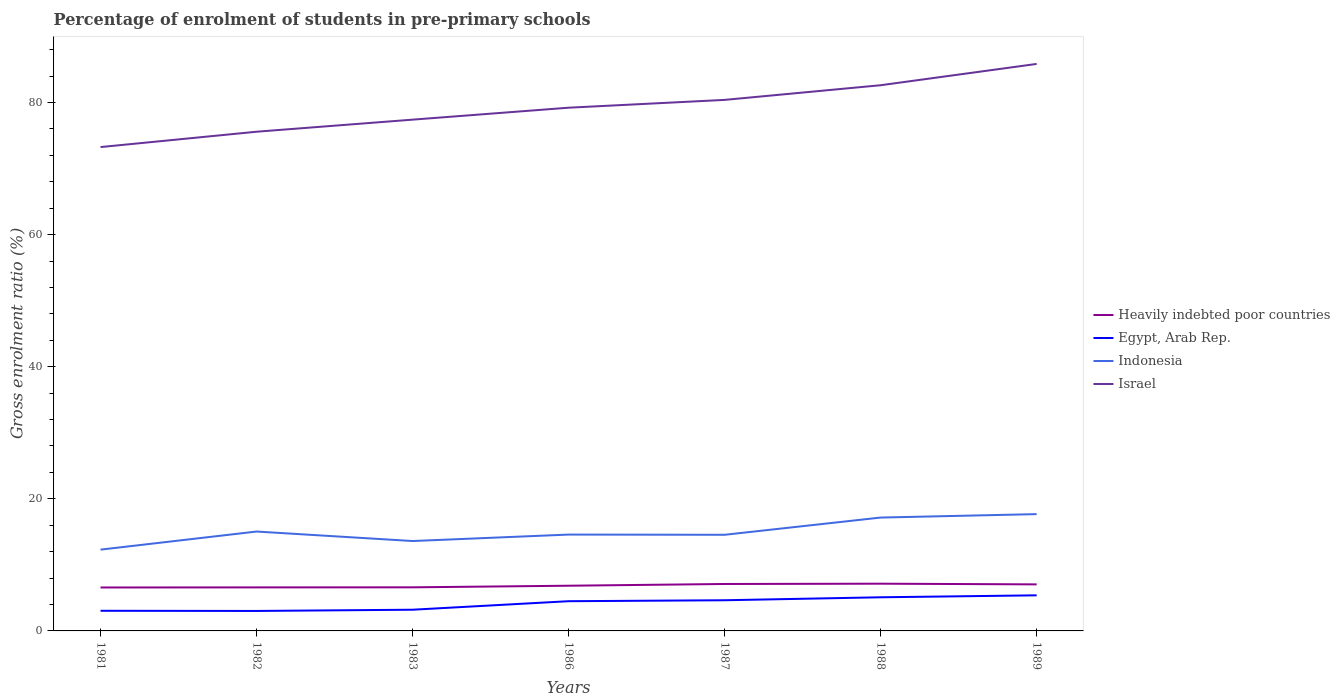How many different coloured lines are there?
Ensure brevity in your answer.  4. Does the line corresponding to Israel intersect with the line corresponding to Egypt, Arab Rep.?
Your answer should be compact. No. Is the number of lines equal to the number of legend labels?
Make the answer very short. Yes. Across all years, what is the maximum percentage of students enrolled in pre-primary schools in Indonesia?
Your answer should be compact. 12.31. What is the total percentage of students enrolled in pre-primary schools in Heavily indebted poor countries in the graph?
Give a very brief answer. -0.27. What is the difference between the highest and the second highest percentage of students enrolled in pre-primary schools in Indonesia?
Make the answer very short. 5.38. How many lines are there?
Your response must be concise. 4. How many years are there in the graph?
Make the answer very short. 7. Does the graph contain any zero values?
Your response must be concise. No. What is the title of the graph?
Provide a short and direct response. Percentage of enrolment of students in pre-primary schools. What is the label or title of the Y-axis?
Make the answer very short. Gross enrolment ratio (%). What is the Gross enrolment ratio (%) of Heavily indebted poor countries in 1981?
Your response must be concise. 6.58. What is the Gross enrolment ratio (%) in Egypt, Arab Rep. in 1981?
Your answer should be very brief. 3.05. What is the Gross enrolment ratio (%) in Indonesia in 1981?
Your answer should be very brief. 12.31. What is the Gross enrolment ratio (%) of Israel in 1981?
Keep it short and to the point. 73.25. What is the Gross enrolment ratio (%) in Heavily indebted poor countries in 1982?
Provide a succinct answer. 6.59. What is the Gross enrolment ratio (%) of Egypt, Arab Rep. in 1982?
Ensure brevity in your answer.  3.02. What is the Gross enrolment ratio (%) of Indonesia in 1982?
Your response must be concise. 15.04. What is the Gross enrolment ratio (%) in Israel in 1982?
Give a very brief answer. 75.57. What is the Gross enrolment ratio (%) in Heavily indebted poor countries in 1983?
Your answer should be very brief. 6.6. What is the Gross enrolment ratio (%) in Egypt, Arab Rep. in 1983?
Make the answer very short. 3.21. What is the Gross enrolment ratio (%) of Indonesia in 1983?
Offer a terse response. 13.61. What is the Gross enrolment ratio (%) of Israel in 1983?
Your answer should be very brief. 77.4. What is the Gross enrolment ratio (%) in Heavily indebted poor countries in 1986?
Provide a succinct answer. 6.84. What is the Gross enrolment ratio (%) in Egypt, Arab Rep. in 1986?
Your answer should be compact. 4.5. What is the Gross enrolment ratio (%) in Indonesia in 1986?
Offer a terse response. 14.59. What is the Gross enrolment ratio (%) in Israel in 1986?
Provide a succinct answer. 79.21. What is the Gross enrolment ratio (%) of Heavily indebted poor countries in 1987?
Provide a succinct answer. 7.11. What is the Gross enrolment ratio (%) in Egypt, Arab Rep. in 1987?
Your answer should be compact. 4.64. What is the Gross enrolment ratio (%) of Indonesia in 1987?
Offer a very short reply. 14.55. What is the Gross enrolment ratio (%) of Israel in 1987?
Your answer should be compact. 80.39. What is the Gross enrolment ratio (%) of Heavily indebted poor countries in 1988?
Your response must be concise. 7.15. What is the Gross enrolment ratio (%) of Egypt, Arab Rep. in 1988?
Your answer should be very brief. 5.09. What is the Gross enrolment ratio (%) in Indonesia in 1988?
Offer a very short reply. 17.16. What is the Gross enrolment ratio (%) in Israel in 1988?
Your answer should be very brief. 82.61. What is the Gross enrolment ratio (%) in Heavily indebted poor countries in 1989?
Your answer should be very brief. 7.05. What is the Gross enrolment ratio (%) of Egypt, Arab Rep. in 1989?
Your answer should be compact. 5.39. What is the Gross enrolment ratio (%) of Indonesia in 1989?
Ensure brevity in your answer.  17.68. What is the Gross enrolment ratio (%) in Israel in 1989?
Offer a very short reply. 85.83. Across all years, what is the maximum Gross enrolment ratio (%) of Heavily indebted poor countries?
Your answer should be compact. 7.15. Across all years, what is the maximum Gross enrolment ratio (%) in Egypt, Arab Rep.?
Make the answer very short. 5.39. Across all years, what is the maximum Gross enrolment ratio (%) of Indonesia?
Make the answer very short. 17.68. Across all years, what is the maximum Gross enrolment ratio (%) of Israel?
Make the answer very short. 85.83. Across all years, what is the minimum Gross enrolment ratio (%) in Heavily indebted poor countries?
Your answer should be very brief. 6.58. Across all years, what is the minimum Gross enrolment ratio (%) of Egypt, Arab Rep.?
Offer a very short reply. 3.02. Across all years, what is the minimum Gross enrolment ratio (%) in Indonesia?
Ensure brevity in your answer.  12.31. Across all years, what is the minimum Gross enrolment ratio (%) of Israel?
Give a very brief answer. 73.25. What is the total Gross enrolment ratio (%) in Heavily indebted poor countries in the graph?
Offer a terse response. 47.91. What is the total Gross enrolment ratio (%) in Egypt, Arab Rep. in the graph?
Make the answer very short. 28.91. What is the total Gross enrolment ratio (%) in Indonesia in the graph?
Offer a very short reply. 104.94. What is the total Gross enrolment ratio (%) of Israel in the graph?
Your response must be concise. 554.26. What is the difference between the Gross enrolment ratio (%) of Heavily indebted poor countries in 1981 and that in 1982?
Make the answer very short. -0.01. What is the difference between the Gross enrolment ratio (%) in Egypt, Arab Rep. in 1981 and that in 1982?
Ensure brevity in your answer.  0.03. What is the difference between the Gross enrolment ratio (%) in Indonesia in 1981 and that in 1982?
Offer a terse response. -2.74. What is the difference between the Gross enrolment ratio (%) of Israel in 1981 and that in 1982?
Offer a terse response. -2.32. What is the difference between the Gross enrolment ratio (%) of Heavily indebted poor countries in 1981 and that in 1983?
Ensure brevity in your answer.  -0.02. What is the difference between the Gross enrolment ratio (%) of Egypt, Arab Rep. in 1981 and that in 1983?
Provide a short and direct response. -0.16. What is the difference between the Gross enrolment ratio (%) in Indonesia in 1981 and that in 1983?
Provide a succinct answer. -1.3. What is the difference between the Gross enrolment ratio (%) of Israel in 1981 and that in 1983?
Ensure brevity in your answer.  -4.15. What is the difference between the Gross enrolment ratio (%) in Heavily indebted poor countries in 1981 and that in 1986?
Your answer should be very brief. -0.27. What is the difference between the Gross enrolment ratio (%) of Egypt, Arab Rep. in 1981 and that in 1986?
Your response must be concise. -1.45. What is the difference between the Gross enrolment ratio (%) of Indonesia in 1981 and that in 1986?
Keep it short and to the point. -2.28. What is the difference between the Gross enrolment ratio (%) of Israel in 1981 and that in 1986?
Your answer should be compact. -5.96. What is the difference between the Gross enrolment ratio (%) in Heavily indebted poor countries in 1981 and that in 1987?
Your response must be concise. -0.53. What is the difference between the Gross enrolment ratio (%) in Egypt, Arab Rep. in 1981 and that in 1987?
Make the answer very short. -1.59. What is the difference between the Gross enrolment ratio (%) of Indonesia in 1981 and that in 1987?
Offer a terse response. -2.25. What is the difference between the Gross enrolment ratio (%) of Israel in 1981 and that in 1987?
Your answer should be very brief. -7.14. What is the difference between the Gross enrolment ratio (%) of Heavily indebted poor countries in 1981 and that in 1988?
Keep it short and to the point. -0.57. What is the difference between the Gross enrolment ratio (%) in Egypt, Arab Rep. in 1981 and that in 1988?
Your answer should be very brief. -2.04. What is the difference between the Gross enrolment ratio (%) in Indonesia in 1981 and that in 1988?
Offer a terse response. -4.86. What is the difference between the Gross enrolment ratio (%) of Israel in 1981 and that in 1988?
Make the answer very short. -9.36. What is the difference between the Gross enrolment ratio (%) in Heavily indebted poor countries in 1981 and that in 1989?
Offer a very short reply. -0.47. What is the difference between the Gross enrolment ratio (%) of Egypt, Arab Rep. in 1981 and that in 1989?
Make the answer very short. -2.34. What is the difference between the Gross enrolment ratio (%) of Indonesia in 1981 and that in 1989?
Offer a terse response. -5.38. What is the difference between the Gross enrolment ratio (%) of Israel in 1981 and that in 1989?
Give a very brief answer. -12.59. What is the difference between the Gross enrolment ratio (%) in Heavily indebted poor countries in 1982 and that in 1983?
Ensure brevity in your answer.  -0.01. What is the difference between the Gross enrolment ratio (%) in Egypt, Arab Rep. in 1982 and that in 1983?
Make the answer very short. -0.19. What is the difference between the Gross enrolment ratio (%) of Indonesia in 1982 and that in 1983?
Offer a very short reply. 1.44. What is the difference between the Gross enrolment ratio (%) in Israel in 1982 and that in 1983?
Offer a terse response. -1.83. What is the difference between the Gross enrolment ratio (%) in Heavily indebted poor countries in 1982 and that in 1986?
Your answer should be very brief. -0.25. What is the difference between the Gross enrolment ratio (%) in Egypt, Arab Rep. in 1982 and that in 1986?
Your answer should be compact. -1.48. What is the difference between the Gross enrolment ratio (%) in Indonesia in 1982 and that in 1986?
Your response must be concise. 0.46. What is the difference between the Gross enrolment ratio (%) in Israel in 1982 and that in 1986?
Make the answer very short. -3.64. What is the difference between the Gross enrolment ratio (%) of Heavily indebted poor countries in 1982 and that in 1987?
Your response must be concise. -0.52. What is the difference between the Gross enrolment ratio (%) in Egypt, Arab Rep. in 1982 and that in 1987?
Keep it short and to the point. -1.62. What is the difference between the Gross enrolment ratio (%) in Indonesia in 1982 and that in 1987?
Keep it short and to the point. 0.49. What is the difference between the Gross enrolment ratio (%) in Israel in 1982 and that in 1987?
Give a very brief answer. -4.82. What is the difference between the Gross enrolment ratio (%) in Heavily indebted poor countries in 1982 and that in 1988?
Give a very brief answer. -0.56. What is the difference between the Gross enrolment ratio (%) of Egypt, Arab Rep. in 1982 and that in 1988?
Offer a terse response. -2.07. What is the difference between the Gross enrolment ratio (%) of Indonesia in 1982 and that in 1988?
Offer a terse response. -2.12. What is the difference between the Gross enrolment ratio (%) in Israel in 1982 and that in 1988?
Your response must be concise. -7.04. What is the difference between the Gross enrolment ratio (%) of Heavily indebted poor countries in 1982 and that in 1989?
Provide a short and direct response. -0.46. What is the difference between the Gross enrolment ratio (%) in Egypt, Arab Rep. in 1982 and that in 1989?
Your answer should be compact. -2.37. What is the difference between the Gross enrolment ratio (%) in Indonesia in 1982 and that in 1989?
Ensure brevity in your answer.  -2.64. What is the difference between the Gross enrolment ratio (%) of Israel in 1982 and that in 1989?
Offer a very short reply. -10.26. What is the difference between the Gross enrolment ratio (%) in Heavily indebted poor countries in 1983 and that in 1986?
Your answer should be compact. -0.24. What is the difference between the Gross enrolment ratio (%) in Egypt, Arab Rep. in 1983 and that in 1986?
Offer a very short reply. -1.29. What is the difference between the Gross enrolment ratio (%) of Indonesia in 1983 and that in 1986?
Offer a very short reply. -0.98. What is the difference between the Gross enrolment ratio (%) of Israel in 1983 and that in 1986?
Give a very brief answer. -1.81. What is the difference between the Gross enrolment ratio (%) in Heavily indebted poor countries in 1983 and that in 1987?
Keep it short and to the point. -0.51. What is the difference between the Gross enrolment ratio (%) of Egypt, Arab Rep. in 1983 and that in 1987?
Offer a terse response. -1.43. What is the difference between the Gross enrolment ratio (%) of Indonesia in 1983 and that in 1987?
Your response must be concise. -0.95. What is the difference between the Gross enrolment ratio (%) in Israel in 1983 and that in 1987?
Your answer should be compact. -2.99. What is the difference between the Gross enrolment ratio (%) of Heavily indebted poor countries in 1983 and that in 1988?
Provide a short and direct response. -0.55. What is the difference between the Gross enrolment ratio (%) of Egypt, Arab Rep. in 1983 and that in 1988?
Ensure brevity in your answer.  -1.88. What is the difference between the Gross enrolment ratio (%) in Indonesia in 1983 and that in 1988?
Your answer should be very brief. -3.55. What is the difference between the Gross enrolment ratio (%) of Israel in 1983 and that in 1988?
Ensure brevity in your answer.  -5.21. What is the difference between the Gross enrolment ratio (%) in Heavily indebted poor countries in 1983 and that in 1989?
Make the answer very short. -0.45. What is the difference between the Gross enrolment ratio (%) in Egypt, Arab Rep. in 1983 and that in 1989?
Give a very brief answer. -2.18. What is the difference between the Gross enrolment ratio (%) of Indonesia in 1983 and that in 1989?
Your answer should be very brief. -4.07. What is the difference between the Gross enrolment ratio (%) in Israel in 1983 and that in 1989?
Give a very brief answer. -8.44. What is the difference between the Gross enrolment ratio (%) of Heavily indebted poor countries in 1986 and that in 1987?
Your answer should be very brief. -0.26. What is the difference between the Gross enrolment ratio (%) of Egypt, Arab Rep. in 1986 and that in 1987?
Your answer should be compact. -0.14. What is the difference between the Gross enrolment ratio (%) in Indonesia in 1986 and that in 1987?
Provide a short and direct response. 0.03. What is the difference between the Gross enrolment ratio (%) in Israel in 1986 and that in 1987?
Keep it short and to the point. -1.18. What is the difference between the Gross enrolment ratio (%) of Heavily indebted poor countries in 1986 and that in 1988?
Offer a very short reply. -0.31. What is the difference between the Gross enrolment ratio (%) in Egypt, Arab Rep. in 1986 and that in 1988?
Ensure brevity in your answer.  -0.59. What is the difference between the Gross enrolment ratio (%) in Indonesia in 1986 and that in 1988?
Your answer should be compact. -2.58. What is the difference between the Gross enrolment ratio (%) in Israel in 1986 and that in 1988?
Make the answer very short. -3.4. What is the difference between the Gross enrolment ratio (%) of Heavily indebted poor countries in 1986 and that in 1989?
Offer a very short reply. -0.2. What is the difference between the Gross enrolment ratio (%) in Egypt, Arab Rep. in 1986 and that in 1989?
Ensure brevity in your answer.  -0.89. What is the difference between the Gross enrolment ratio (%) in Indonesia in 1986 and that in 1989?
Provide a succinct answer. -3.1. What is the difference between the Gross enrolment ratio (%) of Israel in 1986 and that in 1989?
Offer a very short reply. -6.63. What is the difference between the Gross enrolment ratio (%) of Heavily indebted poor countries in 1987 and that in 1988?
Provide a short and direct response. -0.04. What is the difference between the Gross enrolment ratio (%) of Egypt, Arab Rep. in 1987 and that in 1988?
Offer a very short reply. -0.45. What is the difference between the Gross enrolment ratio (%) of Indonesia in 1987 and that in 1988?
Provide a succinct answer. -2.61. What is the difference between the Gross enrolment ratio (%) in Israel in 1987 and that in 1988?
Your response must be concise. -2.22. What is the difference between the Gross enrolment ratio (%) of Heavily indebted poor countries in 1987 and that in 1989?
Make the answer very short. 0.06. What is the difference between the Gross enrolment ratio (%) in Egypt, Arab Rep. in 1987 and that in 1989?
Keep it short and to the point. -0.74. What is the difference between the Gross enrolment ratio (%) of Indonesia in 1987 and that in 1989?
Provide a short and direct response. -3.13. What is the difference between the Gross enrolment ratio (%) in Israel in 1987 and that in 1989?
Make the answer very short. -5.44. What is the difference between the Gross enrolment ratio (%) of Heavily indebted poor countries in 1988 and that in 1989?
Provide a short and direct response. 0.1. What is the difference between the Gross enrolment ratio (%) of Egypt, Arab Rep. in 1988 and that in 1989?
Your answer should be very brief. -0.29. What is the difference between the Gross enrolment ratio (%) of Indonesia in 1988 and that in 1989?
Keep it short and to the point. -0.52. What is the difference between the Gross enrolment ratio (%) in Israel in 1988 and that in 1989?
Offer a terse response. -3.22. What is the difference between the Gross enrolment ratio (%) of Heavily indebted poor countries in 1981 and the Gross enrolment ratio (%) of Egypt, Arab Rep. in 1982?
Your answer should be very brief. 3.55. What is the difference between the Gross enrolment ratio (%) of Heavily indebted poor countries in 1981 and the Gross enrolment ratio (%) of Indonesia in 1982?
Your answer should be compact. -8.47. What is the difference between the Gross enrolment ratio (%) of Heavily indebted poor countries in 1981 and the Gross enrolment ratio (%) of Israel in 1982?
Keep it short and to the point. -69. What is the difference between the Gross enrolment ratio (%) in Egypt, Arab Rep. in 1981 and the Gross enrolment ratio (%) in Indonesia in 1982?
Provide a succinct answer. -11.99. What is the difference between the Gross enrolment ratio (%) of Egypt, Arab Rep. in 1981 and the Gross enrolment ratio (%) of Israel in 1982?
Your answer should be compact. -72.52. What is the difference between the Gross enrolment ratio (%) of Indonesia in 1981 and the Gross enrolment ratio (%) of Israel in 1982?
Provide a short and direct response. -63.27. What is the difference between the Gross enrolment ratio (%) in Heavily indebted poor countries in 1981 and the Gross enrolment ratio (%) in Egypt, Arab Rep. in 1983?
Your response must be concise. 3.37. What is the difference between the Gross enrolment ratio (%) in Heavily indebted poor countries in 1981 and the Gross enrolment ratio (%) in Indonesia in 1983?
Keep it short and to the point. -7.03. What is the difference between the Gross enrolment ratio (%) of Heavily indebted poor countries in 1981 and the Gross enrolment ratio (%) of Israel in 1983?
Make the answer very short. -70.82. What is the difference between the Gross enrolment ratio (%) of Egypt, Arab Rep. in 1981 and the Gross enrolment ratio (%) of Indonesia in 1983?
Your response must be concise. -10.56. What is the difference between the Gross enrolment ratio (%) in Egypt, Arab Rep. in 1981 and the Gross enrolment ratio (%) in Israel in 1983?
Ensure brevity in your answer.  -74.35. What is the difference between the Gross enrolment ratio (%) of Indonesia in 1981 and the Gross enrolment ratio (%) of Israel in 1983?
Provide a succinct answer. -65.09. What is the difference between the Gross enrolment ratio (%) of Heavily indebted poor countries in 1981 and the Gross enrolment ratio (%) of Egypt, Arab Rep. in 1986?
Offer a terse response. 2.08. What is the difference between the Gross enrolment ratio (%) in Heavily indebted poor countries in 1981 and the Gross enrolment ratio (%) in Indonesia in 1986?
Provide a succinct answer. -8.01. What is the difference between the Gross enrolment ratio (%) of Heavily indebted poor countries in 1981 and the Gross enrolment ratio (%) of Israel in 1986?
Offer a terse response. -72.63. What is the difference between the Gross enrolment ratio (%) of Egypt, Arab Rep. in 1981 and the Gross enrolment ratio (%) of Indonesia in 1986?
Offer a terse response. -11.54. What is the difference between the Gross enrolment ratio (%) of Egypt, Arab Rep. in 1981 and the Gross enrolment ratio (%) of Israel in 1986?
Offer a terse response. -76.16. What is the difference between the Gross enrolment ratio (%) of Indonesia in 1981 and the Gross enrolment ratio (%) of Israel in 1986?
Your answer should be very brief. -66.9. What is the difference between the Gross enrolment ratio (%) of Heavily indebted poor countries in 1981 and the Gross enrolment ratio (%) of Egypt, Arab Rep. in 1987?
Give a very brief answer. 1.93. What is the difference between the Gross enrolment ratio (%) in Heavily indebted poor countries in 1981 and the Gross enrolment ratio (%) in Indonesia in 1987?
Offer a very short reply. -7.98. What is the difference between the Gross enrolment ratio (%) in Heavily indebted poor countries in 1981 and the Gross enrolment ratio (%) in Israel in 1987?
Make the answer very short. -73.81. What is the difference between the Gross enrolment ratio (%) of Egypt, Arab Rep. in 1981 and the Gross enrolment ratio (%) of Indonesia in 1987?
Your response must be concise. -11.5. What is the difference between the Gross enrolment ratio (%) of Egypt, Arab Rep. in 1981 and the Gross enrolment ratio (%) of Israel in 1987?
Offer a terse response. -77.34. What is the difference between the Gross enrolment ratio (%) in Indonesia in 1981 and the Gross enrolment ratio (%) in Israel in 1987?
Your answer should be very brief. -68.08. What is the difference between the Gross enrolment ratio (%) in Heavily indebted poor countries in 1981 and the Gross enrolment ratio (%) in Egypt, Arab Rep. in 1988?
Your response must be concise. 1.48. What is the difference between the Gross enrolment ratio (%) of Heavily indebted poor countries in 1981 and the Gross enrolment ratio (%) of Indonesia in 1988?
Offer a terse response. -10.59. What is the difference between the Gross enrolment ratio (%) of Heavily indebted poor countries in 1981 and the Gross enrolment ratio (%) of Israel in 1988?
Provide a succinct answer. -76.04. What is the difference between the Gross enrolment ratio (%) of Egypt, Arab Rep. in 1981 and the Gross enrolment ratio (%) of Indonesia in 1988?
Make the answer very short. -14.11. What is the difference between the Gross enrolment ratio (%) in Egypt, Arab Rep. in 1981 and the Gross enrolment ratio (%) in Israel in 1988?
Provide a short and direct response. -79.56. What is the difference between the Gross enrolment ratio (%) in Indonesia in 1981 and the Gross enrolment ratio (%) in Israel in 1988?
Offer a very short reply. -70.31. What is the difference between the Gross enrolment ratio (%) in Heavily indebted poor countries in 1981 and the Gross enrolment ratio (%) in Egypt, Arab Rep. in 1989?
Provide a succinct answer. 1.19. What is the difference between the Gross enrolment ratio (%) of Heavily indebted poor countries in 1981 and the Gross enrolment ratio (%) of Indonesia in 1989?
Offer a very short reply. -11.11. What is the difference between the Gross enrolment ratio (%) in Heavily indebted poor countries in 1981 and the Gross enrolment ratio (%) in Israel in 1989?
Ensure brevity in your answer.  -79.26. What is the difference between the Gross enrolment ratio (%) in Egypt, Arab Rep. in 1981 and the Gross enrolment ratio (%) in Indonesia in 1989?
Provide a short and direct response. -14.63. What is the difference between the Gross enrolment ratio (%) of Egypt, Arab Rep. in 1981 and the Gross enrolment ratio (%) of Israel in 1989?
Keep it short and to the point. -82.78. What is the difference between the Gross enrolment ratio (%) in Indonesia in 1981 and the Gross enrolment ratio (%) in Israel in 1989?
Your answer should be very brief. -73.53. What is the difference between the Gross enrolment ratio (%) in Heavily indebted poor countries in 1982 and the Gross enrolment ratio (%) in Egypt, Arab Rep. in 1983?
Offer a terse response. 3.38. What is the difference between the Gross enrolment ratio (%) of Heavily indebted poor countries in 1982 and the Gross enrolment ratio (%) of Indonesia in 1983?
Your answer should be compact. -7.02. What is the difference between the Gross enrolment ratio (%) in Heavily indebted poor countries in 1982 and the Gross enrolment ratio (%) in Israel in 1983?
Give a very brief answer. -70.81. What is the difference between the Gross enrolment ratio (%) in Egypt, Arab Rep. in 1982 and the Gross enrolment ratio (%) in Indonesia in 1983?
Your answer should be very brief. -10.59. What is the difference between the Gross enrolment ratio (%) of Egypt, Arab Rep. in 1982 and the Gross enrolment ratio (%) of Israel in 1983?
Your answer should be very brief. -74.38. What is the difference between the Gross enrolment ratio (%) of Indonesia in 1982 and the Gross enrolment ratio (%) of Israel in 1983?
Provide a succinct answer. -62.35. What is the difference between the Gross enrolment ratio (%) of Heavily indebted poor countries in 1982 and the Gross enrolment ratio (%) of Egypt, Arab Rep. in 1986?
Ensure brevity in your answer.  2.09. What is the difference between the Gross enrolment ratio (%) of Heavily indebted poor countries in 1982 and the Gross enrolment ratio (%) of Indonesia in 1986?
Ensure brevity in your answer.  -8. What is the difference between the Gross enrolment ratio (%) in Heavily indebted poor countries in 1982 and the Gross enrolment ratio (%) in Israel in 1986?
Give a very brief answer. -72.62. What is the difference between the Gross enrolment ratio (%) of Egypt, Arab Rep. in 1982 and the Gross enrolment ratio (%) of Indonesia in 1986?
Ensure brevity in your answer.  -11.56. What is the difference between the Gross enrolment ratio (%) of Egypt, Arab Rep. in 1982 and the Gross enrolment ratio (%) of Israel in 1986?
Offer a terse response. -76.19. What is the difference between the Gross enrolment ratio (%) in Indonesia in 1982 and the Gross enrolment ratio (%) in Israel in 1986?
Provide a short and direct response. -64.16. What is the difference between the Gross enrolment ratio (%) of Heavily indebted poor countries in 1982 and the Gross enrolment ratio (%) of Egypt, Arab Rep. in 1987?
Provide a short and direct response. 1.95. What is the difference between the Gross enrolment ratio (%) of Heavily indebted poor countries in 1982 and the Gross enrolment ratio (%) of Indonesia in 1987?
Your response must be concise. -7.96. What is the difference between the Gross enrolment ratio (%) in Heavily indebted poor countries in 1982 and the Gross enrolment ratio (%) in Israel in 1987?
Your answer should be very brief. -73.8. What is the difference between the Gross enrolment ratio (%) in Egypt, Arab Rep. in 1982 and the Gross enrolment ratio (%) in Indonesia in 1987?
Offer a terse response. -11.53. What is the difference between the Gross enrolment ratio (%) in Egypt, Arab Rep. in 1982 and the Gross enrolment ratio (%) in Israel in 1987?
Provide a short and direct response. -77.37. What is the difference between the Gross enrolment ratio (%) in Indonesia in 1982 and the Gross enrolment ratio (%) in Israel in 1987?
Provide a succinct answer. -65.35. What is the difference between the Gross enrolment ratio (%) of Heavily indebted poor countries in 1982 and the Gross enrolment ratio (%) of Egypt, Arab Rep. in 1988?
Provide a short and direct response. 1.5. What is the difference between the Gross enrolment ratio (%) of Heavily indebted poor countries in 1982 and the Gross enrolment ratio (%) of Indonesia in 1988?
Provide a succinct answer. -10.57. What is the difference between the Gross enrolment ratio (%) of Heavily indebted poor countries in 1982 and the Gross enrolment ratio (%) of Israel in 1988?
Ensure brevity in your answer.  -76.02. What is the difference between the Gross enrolment ratio (%) of Egypt, Arab Rep. in 1982 and the Gross enrolment ratio (%) of Indonesia in 1988?
Make the answer very short. -14.14. What is the difference between the Gross enrolment ratio (%) of Egypt, Arab Rep. in 1982 and the Gross enrolment ratio (%) of Israel in 1988?
Your answer should be very brief. -79.59. What is the difference between the Gross enrolment ratio (%) of Indonesia in 1982 and the Gross enrolment ratio (%) of Israel in 1988?
Keep it short and to the point. -67.57. What is the difference between the Gross enrolment ratio (%) of Heavily indebted poor countries in 1982 and the Gross enrolment ratio (%) of Egypt, Arab Rep. in 1989?
Your response must be concise. 1.2. What is the difference between the Gross enrolment ratio (%) of Heavily indebted poor countries in 1982 and the Gross enrolment ratio (%) of Indonesia in 1989?
Offer a terse response. -11.09. What is the difference between the Gross enrolment ratio (%) in Heavily indebted poor countries in 1982 and the Gross enrolment ratio (%) in Israel in 1989?
Offer a very short reply. -79.25. What is the difference between the Gross enrolment ratio (%) of Egypt, Arab Rep. in 1982 and the Gross enrolment ratio (%) of Indonesia in 1989?
Your response must be concise. -14.66. What is the difference between the Gross enrolment ratio (%) in Egypt, Arab Rep. in 1982 and the Gross enrolment ratio (%) in Israel in 1989?
Your response must be concise. -82.81. What is the difference between the Gross enrolment ratio (%) in Indonesia in 1982 and the Gross enrolment ratio (%) in Israel in 1989?
Keep it short and to the point. -70.79. What is the difference between the Gross enrolment ratio (%) of Heavily indebted poor countries in 1983 and the Gross enrolment ratio (%) of Egypt, Arab Rep. in 1986?
Give a very brief answer. 2.1. What is the difference between the Gross enrolment ratio (%) in Heavily indebted poor countries in 1983 and the Gross enrolment ratio (%) in Indonesia in 1986?
Ensure brevity in your answer.  -7.99. What is the difference between the Gross enrolment ratio (%) of Heavily indebted poor countries in 1983 and the Gross enrolment ratio (%) of Israel in 1986?
Provide a short and direct response. -72.61. What is the difference between the Gross enrolment ratio (%) of Egypt, Arab Rep. in 1983 and the Gross enrolment ratio (%) of Indonesia in 1986?
Offer a very short reply. -11.38. What is the difference between the Gross enrolment ratio (%) in Egypt, Arab Rep. in 1983 and the Gross enrolment ratio (%) in Israel in 1986?
Give a very brief answer. -76. What is the difference between the Gross enrolment ratio (%) in Indonesia in 1983 and the Gross enrolment ratio (%) in Israel in 1986?
Make the answer very short. -65.6. What is the difference between the Gross enrolment ratio (%) in Heavily indebted poor countries in 1983 and the Gross enrolment ratio (%) in Egypt, Arab Rep. in 1987?
Your answer should be compact. 1.95. What is the difference between the Gross enrolment ratio (%) in Heavily indebted poor countries in 1983 and the Gross enrolment ratio (%) in Indonesia in 1987?
Make the answer very short. -7.96. What is the difference between the Gross enrolment ratio (%) of Heavily indebted poor countries in 1983 and the Gross enrolment ratio (%) of Israel in 1987?
Keep it short and to the point. -73.79. What is the difference between the Gross enrolment ratio (%) in Egypt, Arab Rep. in 1983 and the Gross enrolment ratio (%) in Indonesia in 1987?
Ensure brevity in your answer.  -11.34. What is the difference between the Gross enrolment ratio (%) of Egypt, Arab Rep. in 1983 and the Gross enrolment ratio (%) of Israel in 1987?
Keep it short and to the point. -77.18. What is the difference between the Gross enrolment ratio (%) of Indonesia in 1983 and the Gross enrolment ratio (%) of Israel in 1987?
Ensure brevity in your answer.  -66.78. What is the difference between the Gross enrolment ratio (%) in Heavily indebted poor countries in 1983 and the Gross enrolment ratio (%) in Egypt, Arab Rep. in 1988?
Keep it short and to the point. 1.5. What is the difference between the Gross enrolment ratio (%) in Heavily indebted poor countries in 1983 and the Gross enrolment ratio (%) in Indonesia in 1988?
Give a very brief answer. -10.56. What is the difference between the Gross enrolment ratio (%) in Heavily indebted poor countries in 1983 and the Gross enrolment ratio (%) in Israel in 1988?
Your answer should be compact. -76.01. What is the difference between the Gross enrolment ratio (%) of Egypt, Arab Rep. in 1983 and the Gross enrolment ratio (%) of Indonesia in 1988?
Provide a short and direct response. -13.95. What is the difference between the Gross enrolment ratio (%) of Egypt, Arab Rep. in 1983 and the Gross enrolment ratio (%) of Israel in 1988?
Offer a terse response. -79.4. What is the difference between the Gross enrolment ratio (%) of Indonesia in 1983 and the Gross enrolment ratio (%) of Israel in 1988?
Offer a very short reply. -69. What is the difference between the Gross enrolment ratio (%) of Heavily indebted poor countries in 1983 and the Gross enrolment ratio (%) of Egypt, Arab Rep. in 1989?
Keep it short and to the point. 1.21. What is the difference between the Gross enrolment ratio (%) in Heavily indebted poor countries in 1983 and the Gross enrolment ratio (%) in Indonesia in 1989?
Offer a terse response. -11.08. What is the difference between the Gross enrolment ratio (%) in Heavily indebted poor countries in 1983 and the Gross enrolment ratio (%) in Israel in 1989?
Make the answer very short. -79.24. What is the difference between the Gross enrolment ratio (%) in Egypt, Arab Rep. in 1983 and the Gross enrolment ratio (%) in Indonesia in 1989?
Offer a terse response. -14.47. What is the difference between the Gross enrolment ratio (%) of Egypt, Arab Rep. in 1983 and the Gross enrolment ratio (%) of Israel in 1989?
Your answer should be very brief. -82.62. What is the difference between the Gross enrolment ratio (%) in Indonesia in 1983 and the Gross enrolment ratio (%) in Israel in 1989?
Ensure brevity in your answer.  -72.23. What is the difference between the Gross enrolment ratio (%) of Heavily indebted poor countries in 1986 and the Gross enrolment ratio (%) of Egypt, Arab Rep. in 1987?
Provide a succinct answer. 2.2. What is the difference between the Gross enrolment ratio (%) in Heavily indebted poor countries in 1986 and the Gross enrolment ratio (%) in Indonesia in 1987?
Your response must be concise. -7.71. What is the difference between the Gross enrolment ratio (%) in Heavily indebted poor countries in 1986 and the Gross enrolment ratio (%) in Israel in 1987?
Ensure brevity in your answer.  -73.55. What is the difference between the Gross enrolment ratio (%) in Egypt, Arab Rep. in 1986 and the Gross enrolment ratio (%) in Indonesia in 1987?
Give a very brief answer. -10.05. What is the difference between the Gross enrolment ratio (%) of Egypt, Arab Rep. in 1986 and the Gross enrolment ratio (%) of Israel in 1987?
Your answer should be very brief. -75.89. What is the difference between the Gross enrolment ratio (%) of Indonesia in 1986 and the Gross enrolment ratio (%) of Israel in 1987?
Give a very brief answer. -65.8. What is the difference between the Gross enrolment ratio (%) in Heavily indebted poor countries in 1986 and the Gross enrolment ratio (%) in Egypt, Arab Rep. in 1988?
Provide a short and direct response. 1.75. What is the difference between the Gross enrolment ratio (%) of Heavily indebted poor countries in 1986 and the Gross enrolment ratio (%) of Indonesia in 1988?
Provide a succinct answer. -10.32. What is the difference between the Gross enrolment ratio (%) in Heavily indebted poor countries in 1986 and the Gross enrolment ratio (%) in Israel in 1988?
Offer a terse response. -75.77. What is the difference between the Gross enrolment ratio (%) in Egypt, Arab Rep. in 1986 and the Gross enrolment ratio (%) in Indonesia in 1988?
Provide a succinct answer. -12.66. What is the difference between the Gross enrolment ratio (%) of Egypt, Arab Rep. in 1986 and the Gross enrolment ratio (%) of Israel in 1988?
Offer a very short reply. -78.11. What is the difference between the Gross enrolment ratio (%) in Indonesia in 1986 and the Gross enrolment ratio (%) in Israel in 1988?
Make the answer very short. -68.03. What is the difference between the Gross enrolment ratio (%) of Heavily indebted poor countries in 1986 and the Gross enrolment ratio (%) of Egypt, Arab Rep. in 1989?
Make the answer very short. 1.46. What is the difference between the Gross enrolment ratio (%) of Heavily indebted poor countries in 1986 and the Gross enrolment ratio (%) of Indonesia in 1989?
Offer a terse response. -10.84. What is the difference between the Gross enrolment ratio (%) in Heavily indebted poor countries in 1986 and the Gross enrolment ratio (%) in Israel in 1989?
Give a very brief answer. -78.99. What is the difference between the Gross enrolment ratio (%) of Egypt, Arab Rep. in 1986 and the Gross enrolment ratio (%) of Indonesia in 1989?
Provide a short and direct response. -13.18. What is the difference between the Gross enrolment ratio (%) in Egypt, Arab Rep. in 1986 and the Gross enrolment ratio (%) in Israel in 1989?
Your answer should be compact. -81.34. What is the difference between the Gross enrolment ratio (%) in Indonesia in 1986 and the Gross enrolment ratio (%) in Israel in 1989?
Provide a succinct answer. -71.25. What is the difference between the Gross enrolment ratio (%) in Heavily indebted poor countries in 1987 and the Gross enrolment ratio (%) in Egypt, Arab Rep. in 1988?
Make the answer very short. 2.01. What is the difference between the Gross enrolment ratio (%) of Heavily indebted poor countries in 1987 and the Gross enrolment ratio (%) of Indonesia in 1988?
Keep it short and to the point. -10.05. What is the difference between the Gross enrolment ratio (%) in Heavily indebted poor countries in 1987 and the Gross enrolment ratio (%) in Israel in 1988?
Keep it short and to the point. -75.5. What is the difference between the Gross enrolment ratio (%) of Egypt, Arab Rep. in 1987 and the Gross enrolment ratio (%) of Indonesia in 1988?
Make the answer very short. -12.52. What is the difference between the Gross enrolment ratio (%) in Egypt, Arab Rep. in 1987 and the Gross enrolment ratio (%) in Israel in 1988?
Your answer should be very brief. -77.97. What is the difference between the Gross enrolment ratio (%) in Indonesia in 1987 and the Gross enrolment ratio (%) in Israel in 1988?
Offer a very short reply. -68.06. What is the difference between the Gross enrolment ratio (%) of Heavily indebted poor countries in 1987 and the Gross enrolment ratio (%) of Egypt, Arab Rep. in 1989?
Ensure brevity in your answer.  1.72. What is the difference between the Gross enrolment ratio (%) of Heavily indebted poor countries in 1987 and the Gross enrolment ratio (%) of Indonesia in 1989?
Ensure brevity in your answer.  -10.57. What is the difference between the Gross enrolment ratio (%) of Heavily indebted poor countries in 1987 and the Gross enrolment ratio (%) of Israel in 1989?
Make the answer very short. -78.73. What is the difference between the Gross enrolment ratio (%) in Egypt, Arab Rep. in 1987 and the Gross enrolment ratio (%) in Indonesia in 1989?
Provide a succinct answer. -13.04. What is the difference between the Gross enrolment ratio (%) in Egypt, Arab Rep. in 1987 and the Gross enrolment ratio (%) in Israel in 1989?
Keep it short and to the point. -81.19. What is the difference between the Gross enrolment ratio (%) of Indonesia in 1987 and the Gross enrolment ratio (%) of Israel in 1989?
Your answer should be compact. -71.28. What is the difference between the Gross enrolment ratio (%) of Heavily indebted poor countries in 1988 and the Gross enrolment ratio (%) of Egypt, Arab Rep. in 1989?
Your answer should be compact. 1.76. What is the difference between the Gross enrolment ratio (%) in Heavily indebted poor countries in 1988 and the Gross enrolment ratio (%) in Indonesia in 1989?
Give a very brief answer. -10.53. What is the difference between the Gross enrolment ratio (%) of Heavily indebted poor countries in 1988 and the Gross enrolment ratio (%) of Israel in 1989?
Provide a short and direct response. -78.69. What is the difference between the Gross enrolment ratio (%) of Egypt, Arab Rep. in 1988 and the Gross enrolment ratio (%) of Indonesia in 1989?
Ensure brevity in your answer.  -12.59. What is the difference between the Gross enrolment ratio (%) of Egypt, Arab Rep. in 1988 and the Gross enrolment ratio (%) of Israel in 1989?
Your response must be concise. -80.74. What is the difference between the Gross enrolment ratio (%) in Indonesia in 1988 and the Gross enrolment ratio (%) in Israel in 1989?
Offer a terse response. -68.67. What is the average Gross enrolment ratio (%) of Heavily indebted poor countries per year?
Offer a very short reply. 6.84. What is the average Gross enrolment ratio (%) of Egypt, Arab Rep. per year?
Your response must be concise. 4.13. What is the average Gross enrolment ratio (%) of Indonesia per year?
Ensure brevity in your answer.  14.99. What is the average Gross enrolment ratio (%) of Israel per year?
Ensure brevity in your answer.  79.18. In the year 1981, what is the difference between the Gross enrolment ratio (%) in Heavily indebted poor countries and Gross enrolment ratio (%) in Egypt, Arab Rep.?
Give a very brief answer. 3.53. In the year 1981, what is the difference between the Gross enrolment ratio (%) of Heavily indebted poor countries and Gross enrolment ratio (%) of Indonesia?
Your answer should be very brief. -5.73. In the year 1981, what is the difference between the Gross enrolment ratio (%) of Heavily indebted poor countries and Gross enrolment ratio (%) of Israel?
Your answer should be very brief. -66.67. In the year 1981, what is the difference between the Gross enrolment ratio (%) of Egypt, Arab Rep. and Gross enrolment ratio (%) of Indonesia?
Provide a succinct answer. -9.26. In the year 1981, what is the difference between the Gross enrolment ratio (%) of Egypt, Arab Rep. and Gross enrolment ratio (%) of Israel?
Offer a very short reply. -70.2. In the year 1981, what is the difference between the Gross enrolment ratio (%) of Indonesia and Gross enrolment ratio (%) of Israel?
Your answer should be compact. -60.94. In the year 1982, what is the difference between the Gross enrolment ratio (%) of Heavily indebted poor countries and Gross enrolment ratio (%) of Egypt, Arab Rep.?
Offer a very short reply. 3.57. In the year 1982, what is the difference between the Gross enrolment ratio (%) in Heavily indebted poor countries and Gross enrolment ratio (%) in Indonesia?
Ensure brevity in your answer.  -8.46. In the year 1982, what is the difference between the Gross enrolment ratio (%) of Heavily indebted poor countries and Gross enrolment ratio (%) of Israel?
Offer a terse response. -68.98. In the year 1982, what is the difference between the Gross enrolment ratio (%) of Egypt, Arab Rep. and Gross enrolment ratio (%) of Indonesia?
Your response must be concise. -12.02. In the year 1982, what is the difference between the Gross enrolment ratio (%) of Egypt, Arab Rep. and Gross enrolment ratio (%) of Israel?
Offer a terse response. -72.55. In the year 1982, what is the difference between the Gross enrolment ratio (%) of Indonesia and Gross enrolment ratio (%) of Israel?
Make the answer very short. -60.53. In the year 1983, what is the difference between the Gross enrolment ratio (%) of Heavily indebted poor countries and Gross enrolment ratio (%) of Egypt, Arab Rep.?
Your answer should be compact. 3.39. In the year 1983, what is the difference between the Gross enrolment ratio (%) of Heavily indebted poor countries and Gross enrolment ratio (%) of Indonesia?
Provide a succinct answer. -7.01. In the year 1983, what is the difference between the Gross enrolment ratio (%) of Heavily indebted poor countries and Gross enrolment ratio (%) of Israel?
Keep it short and to the point. -70.8. In the year 1983, what is the difference between the Gross enrolment ratio (%) in Egypt, Arab Rep. and Gross enrolment ratio (%) in Indonesia?
Ensure brevity in your answer.  -10.4. In the year 1983, what is the difference between the Gross enrolment ratio (%) in Egypt, Arab Rep. and Gross enrolment ratio (%) in Israel?
Provide a short and direct response. -74.19. In the year 1983, what is the difference between the Gross enrolment ratio (%) in Indonesia and Gross enrolment ratio (%) in Israel?
Provide a short and direct response. -63.79. In the year 1986, what is the difference between the Gross enrolment ratio (%) in Heavily indebted poor countries and Gross enrolment ratio (%) in Egypt, Arab Rep.?
Offer a very short reply. 2.34. In the year 1986, what is the difference between the Gross enrolment ratio (%) of Heavily indebted poor countries and Gross enrolment ratio (%) of Indonesia?
Offer a very short reply. -7.74. In the year 1986, what is the difference between the Gross enrolment ratio (%) in Heavily indebted poor countries and Gross enrolment ratio (%) in Israel?
Your answer should be very brief. -72.37. In the year 1986, what is the difference between the Gross enrolment ratio (%) of Egypt, Arab Rep. and Gross enrolment ratio (%) of Indonesia?
Keep it short and to the point. -10.09. In the year 1986, what is the difference between the Gross enrolment ratio (%) of Egypt, Arab Rep. and Gross enrolment ratio (%) of Israel?
Make the answer very short. -74.71. In the year 1986, what is the difference between the Gross enrolment ratio (%) of Indonesia and Gross enrolment ratio (%) of Israel?
Provide a short and direct response. -64.62. In the year 1987, what is the difference between the Gross enrolment ratio (%) of Heavily indebted poor countries and Gross enrolment ratio (%) of Egypt, Arab Rep.?
Provide a succinct answer. 2.46. In the year 1987, what is the difference between the Gross enrolment ratio (%) in Heavily indebted poor countries and Gross enrolment ratio (%) in Indonesia?
Give a very brief answer. -7.45. In the year 1987, what is the difference between the Gross enrolment ratio (%) of Heavily indebted poor countries and Gross enrolment ratio (%) of Israel?
Offer a very short reply. -73.28. In the year 1987, what is the difference between the Gross enrolment ratio (%) in Egypt, Arab Rep. and Gross enrolment ratio (%) in Indonesia?
Keep it short and to the point. -9.91. In the year 1987, what is the difference between the Gross enrolment ratio (%) in Egypt, Arab Rep. and Gross enrolment ratio (%) in Israel?
Your answer should be compact. -75.75. In the year 1987, what is the difference between the Gross enrolment ratio (%) in Indonesia and Gross enrolment ratio (%) in Israel?
Ensure brevity in your answer.  -65.84. In the year 1988, what is the difference between the Gross enrolment ratio (%) in Heavily indebted poor countries and Gross enrolment ratio (%) in Egypt, Arab Rep.?
Provide a short and direct response. 2.06. In the year 1988, what is the difference between the Gross enrolment ratio (%) of Heavily indebted poor countries and Gross enrolment ratio (%) of Indonesia?
Give a very brief answer. -10.01. In the year 1988, what is the difference between the Gross enrolment ratio (%) in Heavily indebted poor countries and Gross enrolment ratio (%) in Israel?
Give a very brief answer. -75.46. In the year 1988, what is the difference between the Gross enrolment ratio (%) in Egypt, Arab Rep. and Gross enrolment ratio (%) in Indonesia?
Offer a very short reply. -12.07. In the year 1988, what is the difference between the Gross enrolment ratio (%) in Egypt, Arab Rep. and Gross enrolment ratio (%) in Israel?
Keep it short and to the point. -77.52. In the year 1988, what is the difference between the Gross enrolment ratio (%) of Indonesia and Gross enrolment ratio (%) of Israel?
Provide a short and direct response. -65.45. In the year 1989, what is the difference between the Gross enrolment ratio (%) of Heavily indebted poor countries and Gross enrolment ratio (%) of Egypt, Arab Rep.?
Give a very brief answer. 1.66. In the year 1989, what is the difference between the Gross enrolment ratio (%) in Heavily indebted poor countries and Gross enrolment ratio (%) in Indonesia?
Provide a succinct answer. -10.63. In the year 1989, what is the difference between the Gross enrolment ratio (%) of Heavily indebted poor countries and Gross enrolment ratio (%) of Israel?
Provide a succinct answer. -78.79. In the year 1989, what is the difference between the Gross enrolment ratio (%) of Egypt, Arab Rep. and Gross enrolment ratio (%) of Indonesia?
Make the answer very short. -12.29. In the year 1989, what is the difference between the Gross enrolment ratio (%) of Egypt, Arab Rep. and Gross enrolment ratio (%) of Israel?
Your response must be concise. -80.45. In the year 1989, what is the difference between the Gross enrolment ratio (%) of Indonesia and Gross enrolment ratio (%) of Israel?
Your answer should be compact. -68.15. What is the ratio of the Gross enrolment ratio (%) of Egypt, Arab Rep. in 1981 to that in 1982?
Your response must be concise. 1.01. What is the ratio of the Gross enrolment ratio (%) of Indonesia in 1981 to that in 1982?
Offer a terse response. 0.82. What is the ratio of the Gross enrolment ratio (%) of Israel in 1981 to that in 1982?
Provide a short and direct response. 0.97. What is the ratio of the Gross enrolment ratio (%) in Egypt, Arab Rep. in 1981 to that in 1983?
Offer a terse response. 0.95. What is the ratio of the Gross enrolment ratio (%) in Indonesia in 1981 to that in 1983?
Make the answer very short. 0.9. What is the ratio of the Gross enrolment ratio (%) of Israel in 1981 to that in 1983?
Offer a very short reply. 0.95. What is the ratio of the Gross enrolment ratio (%) of Heavily indebted poor countries in 1981 to that in 1986?
Offer a terse response. 0.96. What is the ratio of the Gross enrolment ratio (%) of Egypt, Arab Rep. in 1981 to that in 1986?
Offer a very short reply. 0.68. What is the ratio of the Gross enrolment ratio (%) in Indonesia in 1981 to that in 1986?
Give a very brief answer. 0.84. What is the ratio of the Gross enrolment ratio (%) of Israel in 1981 to that in 1986?
Your response must be concise. 0.92. What is the ratio of the Gross enrolment ratio (%) of Heavily indebted poor countries in 1981 to that in 1987?
Ensure brevity in your answer.  0.93. What is the ratio of the Gross enrolment ratio (%) in Egypt, Arab Rep. in 1981 to that in 1987?
Keep it short and to the point. 0.66. What is the ratio of the Gross enrolment ratio (%) of Indonesia in 1981 to that in 1987?
Offer a very short reply. 0.85. What is the ratio of the Gross enrolment ratio (%) in Israel in 1981 to that in 1987?
Make the answer very short. 0.91. What is the ratio of the Gross enrolment ratio (%) of Heavily indebted poor countries in 1981 to that in 1988?
Your answer should be compact. 0.92. What is the ratio of the Gross enrolment ratio (%) of Egypt, Arab Rep. in 1981 to that in 1988?
Provide a succinct answer. 0.6. What is the ratio of the Gross enrolment ratio (%) of Indonesia in 1981 to that in 1988?
Offer a terse response. 0.72. What is the ratio of the Gross enrolment ratio (%) in Israel in 1981 to that in 1988?
Give a very brief answer. 0.89. What is the ratio of the Gross enrolment ratio (%) in Heavily indebted poor countries in 1981 to that in 1989?
Your answer should be compact. 0.93. What is the ratio of the Gross enrolment ratio (%) in Egypt, Arab Rep. in 1981 to that in 1989?
Provide a succinct answer. 0.57. What is the ratio of the Gross enrolment ratio (%) in Indonesia in 1981 to that in 1989?
Give a very brief answer. 0.7. What is the ratio of the Gross enrolment ratio (%) in Israel in 1981 to that in 1989?
Make the answer very short. 0.85. What is the ratio of the Gross enrolment ratio (%) in Egypt, Arab Rep. in 1982 to that in 1983?
Give a very brief answer. 0.94. What is the ratio of the Gross enrolment ratio (%) of Indonesia in 1982 to that in 1983?
Keep it short and to the point. 1.11. What is the ratio of the Gross enrolment ratio (%) in Israel in 1982 to that in 1983?
Give a very brief answer. 0.98. What is the ratio of the Gross enrolment ratio (%) of Egypt, Arab Rep. in 1982 to that in 1986?
Offer a very short reply. 0.67. What is the ratio of the Gross enrolment ratio (%) in Indonesia in 1982 to that in 1986?
Your response must be concise. 1.03. What is the ratio of the Gross enrolment ratio (%) of Israel in 1982 to that in 1986?
Your answer should be very brief. 0.95. What is the ratio of the Gross enrolment ratio (%) of Heavily indebted poor countries in 1982 to that in 1987?
Offer a very short reply. 0.93. What is the ratio of the Gross enrolment ratio (%) in Egypt, Arab Rep. in 1982 to that in 1987?
Ensure brevity in your answer.  0.65. What is the ratio of the Gross enrolment ratio (%) in Indonesia in 1982 to that in 1987?
Your answer should be very brief. 1.03. What is the ratio of the Gross enrolment ratio (%) in Israel in 1982 to that in 1987?
Offer a very short reply. 0.94. What is the ratio of the Gross enrolment ratio (%) in Heavily indebted poor countries in 1982 to that in 1988?
Ensure brevity in your answer.  0.92. What is the ratio of the Gross enrolment ratio (%) in Egypt, Arab Rep. in 1982 to that in 1988?
Your answer should be very brief. 0.59. What is the ratio of the Gross enrolment ratio (%) of Indonesia in 1982 to that in 1988?
Your response must be concise. 0.88. What is the ratio of the Gross enrolment ratio (%) in Israel in 1982 to that in 1988?
Provide a short and direct response. 0.91. What is the ratio of the Gross enrolment ratio (%) of Heavily indebted poor countries in 1982 to that in 1989?
Give a very brief answer. 0.94. What is the ratio of the Gross enrolment ratio (%) of Egypt, Arab Rep. in 1982 to that in 1989?
Offer a terse response. 0.56. What is the ratio of the Gross enrolment ratio (%) in Indonesia in 1982 to that in 1989?
Provide a short and direct response. 0.85. What is the ratio of the Gross enrolment ratio (%) of Israel in 1982 to that in 1989?
Your answer should be very brief. 0.88. What is the ratio of the Gross enrolment ratio (%) of Egypt, Arab Rep. in 1983 to that in 1986?
Your answer should be very brief. 0.71. What is the ratio of the Gross enrolment ratio (%) of Indonesia in 1983 to that in 1986?
Offer a terse response. 0.93. What is the ratio of the Gross enrolment ratio (%) of Israel in 1983 to that in 1986?
Make the answer very short. 0.98. What is the ratio of the Gross enrolment ratio (%) of Heavily indebted poor countries in 1983 to that in 1987?
Your answer should be compact. 0.93. What is the ratio of the Gross enrolment ratio (%) of Egypt, Arab Rep. in 1983 to that in 1987?
Your answer should be very brief. 0.69. What is the ratio of the Gross enrolment ratio (%) in Indonesia in 1983 to that in 1987?
Your answer should be compact. 0.94. What is the ratio of the Gross enrolment ratio (%) of Israel in 1983 to that in 1987?
Your response must be concise. 0.96. What is the ratio of the Gross enrolment ratio (%) in Heavily indebted poor countries in 1983 to that in 1988?
Provide a short and direct response. 0.92. What is the ratio of the Gross enrolment ratio (%) in Egypt, Arab Rep. in 1983 to that in 1988?
Ensure brevity in your answer.  0.63. What is the ratio of the Gross enrolment ratio (%) in Indonesia in 1983 to that in 1988?
Your response must be concise. 0.79. What is the ratio of the Gross enrolment ratio (%) in Israel in 1983 to that in 1988?
Keep it short and to the point. 0.94. What is the ratio of the Gross enrolment ratio (%) in Heavily indebted poor countries in 1983 to that in 1989?
Provide a short and direct response. 0.94. What is the ratio of the Gross enrolment ratio (%) in Egypt, Arab Rep. in 1983 to that in 1989?
Ensure brevity in your answer.  0.6. What is the ratio of the Gross enrolment ratio (%) of Indonesia in 1983 to that in 1989?
Keep it short and to the point. 0.77. What is the ratio of the Gross enrolment ratio (%) in Israel in 1983 to that in 1989?
Your answer should be compact. 0.9. What is the ratio of the Gross enrolment ratio (%) in Heavily indebted poor countries in 1986 to that in 1987?
Ensure brevity in your answer.  0.96. What is the ratio of the Gross enrolment ratio (%) in Egypt, Arab Rep. in 1986 to that in 1987?
Your answer should be compact. 0.97. What is the ratio of the Gross enrolment ratio (%) in Heavily indebted poor countries in 1986 to that in 1988?
Your answer should be compact. 0.96. What is the ratio of the Gross enrolment ratio (%) of Egypt, Arab Rep. in 1986 to that in 1988?
Give a very brief answer. 0.88. What is the ratio of the Gross enrolment ratio (%) of Indonesia in 1986 to that in 1988?
Make the answer very short. 0.85. What is the ratio of the Gross enrolment ratio (%) in Israel in 1986 to that in 1988?
Provide a succinct answer. 0.96. What is the ratio of the Gross enrolment ratio (%) in Heavily indebted poor countries in 1986 to that in 1989?
Provide a short and direct response. 0.97. What is the ratio of the Gross enrolment ratio (%) in Egypt, Arab Rep. in 1986 to that in 1989?
Provide a short and direct response. 0.84. What is the ratio of the Gross enrolment ratio (%) of Indonesia in 1986 to that in 1989?
Provide a succinct answer. 0.82. What is the ratio of the Gross enrolment ratio (%) of Israel in 1986 to that in 1989?
Offer a very short reply. 0.92. What is the ratio of the Gross enrolment ratio (%) of Heavily indebted poor countries in 1987 to that in 1988?
Make the answer very short. 0.99. What is the ratio of the Gross enrolment ratio (%) of Egypt, Arab Rep. in 1987 to that in 1988?
Your answer should be compact. 0.91. What is the ratio of the Gross enrolment ratio (%) in Indonesia in 1987 to that in 1988?
Offer a very short reply. 0.85. What is the ratio of the Gross enrolment ratio (%) of Israel in 1987 to that in 1988?
Your answer should be compact. 0.97. What is the ratio of the Gross enrolment ratio (%) in Heavily indebted poor countries in 1987 to that in 1989?
Give a very brief answer. 1.01. What is the ratio of the Gross enrolment ratio (%) in Egypt, Arab Rep. in 1987 to that in 1989?
Provide a succinct answer. 0.86. What is the ratio of the Gross enrolment ratio (%) in Indonesia in 1987 to that in 1989?
Your response must be concise. 0.82. What is the ratio of the Gross enrolment ratio (%) in Israel in 1987 to that in 1989?
Make the answer very short. 0.94. What is the ratio of the Gross enrolment ratio (%) in Heavily indebted poor countries in 1988 to that in 1989?
Ensure brevity in your answer.  1.01. What is the ratio of the Gross enrolment ratio (%) of Egypt, Arab Rep. in 1988 to that in 1989?
Your answer should be very brief. 0.95. What is the ratio of the Gross enrolment ratio (%) in Indonesia in 1988 to that in 1989?
Your answer should be very brief. 0.97. What is the ratio of the Gross enrolment ratio (%) of Israel in 1988 to that in 1989?
Keep it short and to the point. 0.96. What is the difference between the highest and the second highest Gross enrolment ratio (%) of Heavily indebted poor countries?
Your answer should be compact. 0.04. What is the difference between the highest and the second highest Gross enrolment ratio (%) in Egypt, Arab Rep.?
Give a very brief answer. 0.29. What is the difference between the highest and the second highest Gross enrolment ratio (%) of Indonesia?
Your answer should be compact. 0.52. What is the difference between the highest and the second highest Gross enrolment ratio (%) in Israel?
Your answer should be compact. 3.22. What is the difference between the highest and the lowest Gross enrolment ratio (%) of Heavily indebted poor countries?
Give a very brief answer. 0.57. What is the difference between the highest and the lowest Gross enrolment ratio (%) of Egypt, Arab Rep.?
Give a very brief answer. 2.37. What is the difference between the highest and the lowest Gross enrolment ratio (%) of Indonesia?
Provide a short and direct response. 5.38. What is the difference between the highest and the lowest Gross enrolment ratio (%) in Israel?
Offer a terse response. 12.59. 